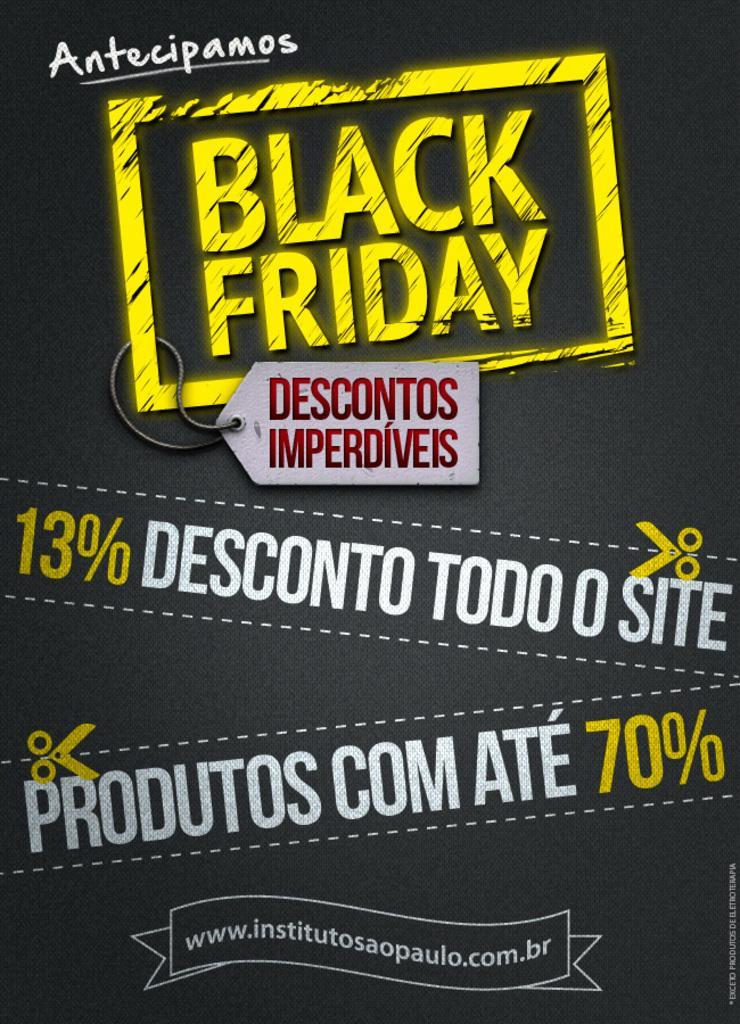Could you give a brief overview of what you see in this image? Here in this picture we can see a poster, on which we can see some text is printed. 